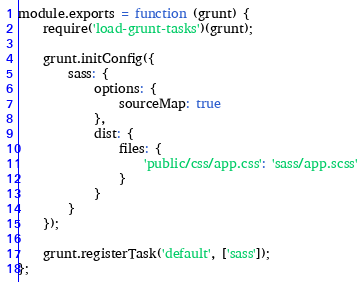Convert code to text. <code><loc_0><loc_0><loc_500><loc_500><_JavaScript_>module.exports = function (grunt) {
    require('load-grunt-tasks')(grunt);

    grunt.initConfig({
        sass: {
            options: {
                sourceMap: true
            },
            dist: {
                files: {
                    'public/css/app.css': 'sass/app.scss'
                }
            }
        }
    });

    grunt.registerTask('default', ['sass']);
};
</code> 